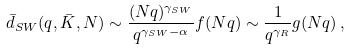<formula> <loc_0><loc_0><loc_500><loc_500>\bar { d } _ { S W } ( q , \bar { K } , N ) \sim \frac { ( N q ) ^ { \gamma _ { S W } } } { q ^ { \gamma _ { S W } - \alpha } } f ( N q ) \sim \frac { 1 } { q ^ { \gamma _ { R } } } g ( N q ) \, ,</formula> 